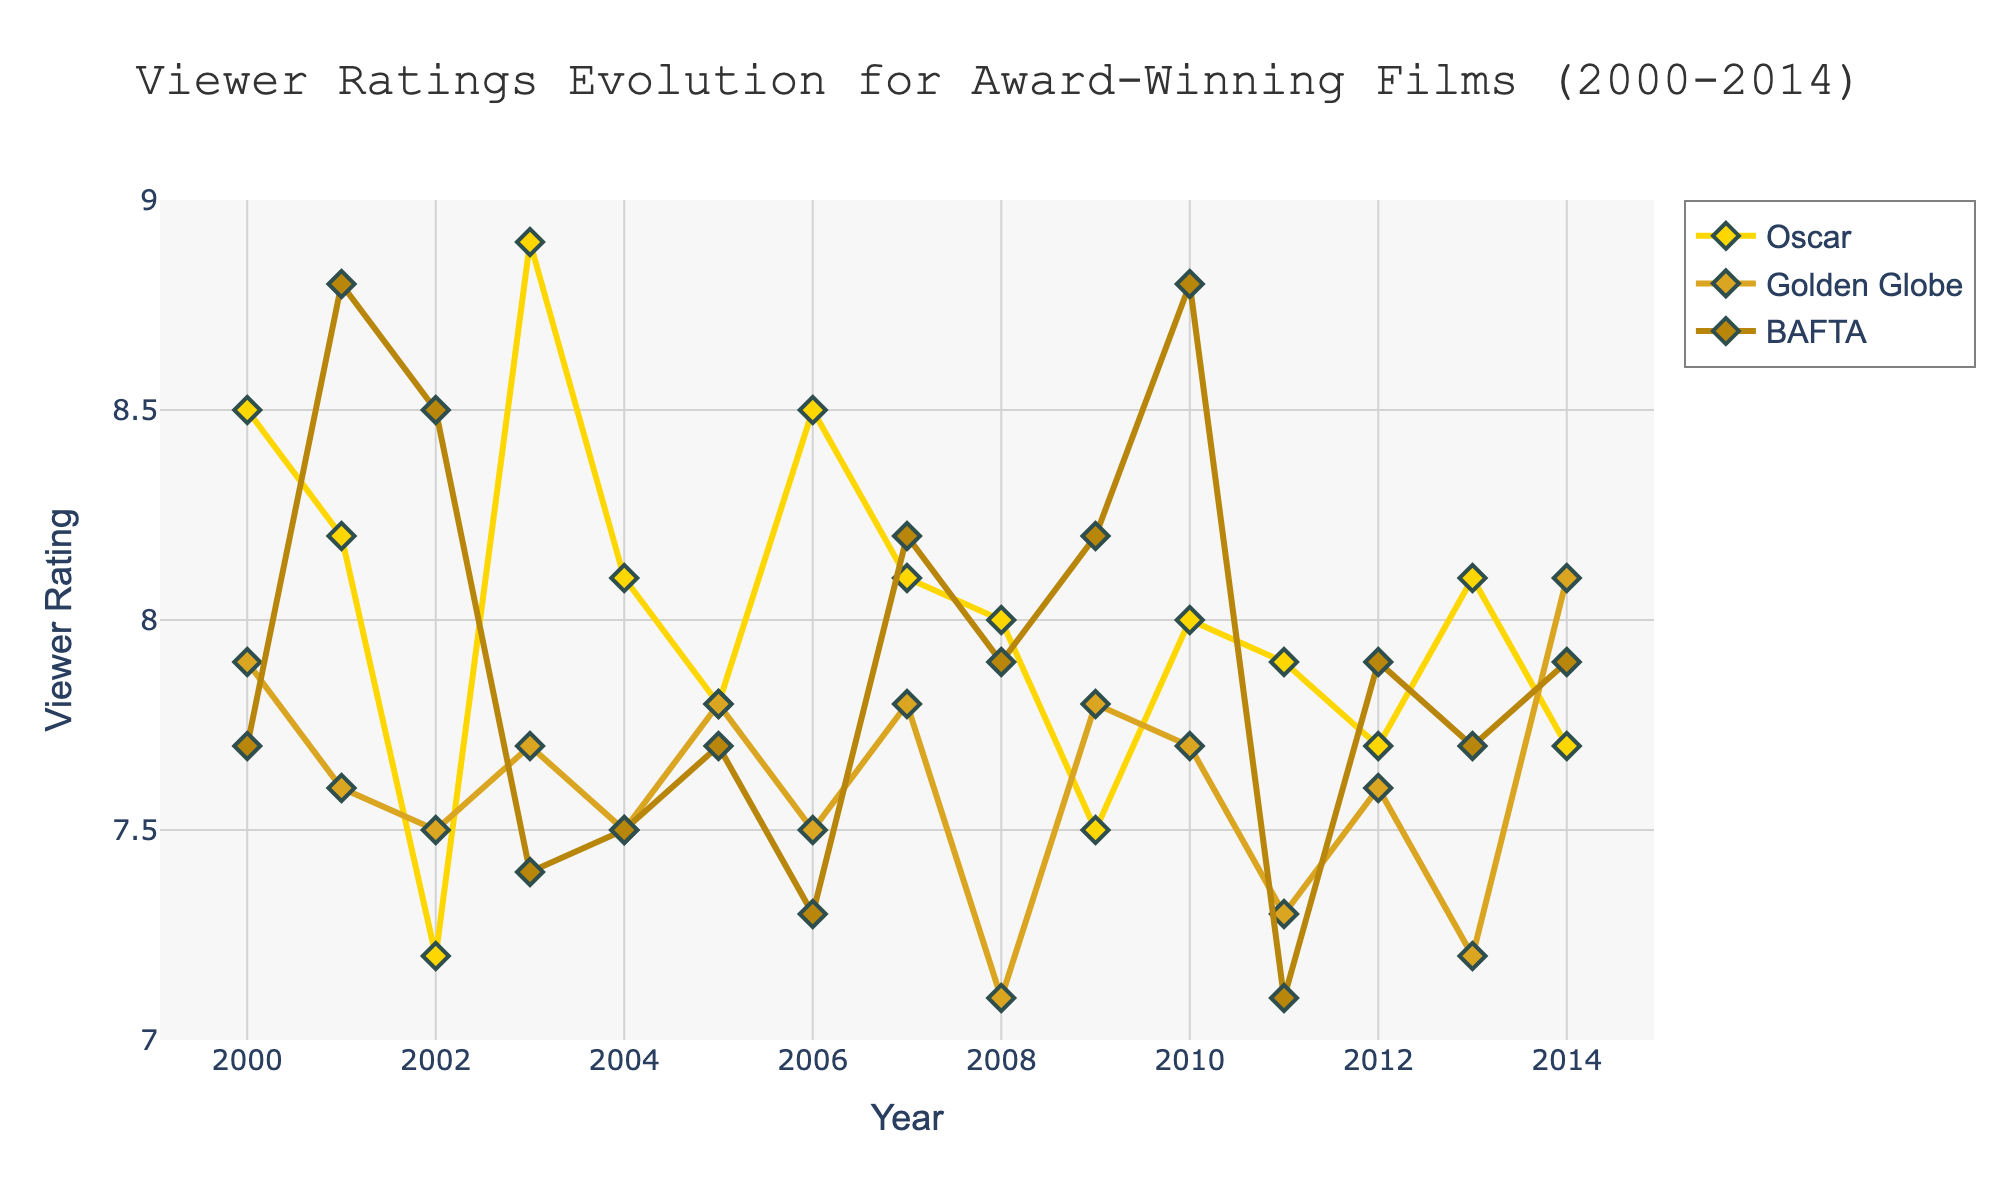What's the title of the figure? The title is usually placed at the top center of the figure. From this figure, the title directly indicates the content.
Answer: Viewer Ratings Evolution for Award-Winning Films (2000-2014) What is the average viewer rating of Oscar-winning films from 2000 to 2014? To find the average, sum up the viewer ratings of all Oscar-winning films and then divide by the number of those films. (8.5+8.2+7.2+8.9+8.1+7.8+8.5+8.1+8.0+7.5+8.0+7.9+7.7+8.1+7.7)/15 = 120.6/15 = 8.04
Answer: 8.04 What's the viewer rating trend for BAFTA-winning films from 2000 to 2014? Observe the general trend by looking at the ratings' increase or decrease over time for BAFTA-winning films. The ratings fluctuate, but there's no strong increasing or decreasing trend.
Answer: Fluctuating with no strong trend Which award type has the highest viewer rating in 2010? Compare the viewer ratings for all award types in the year 2010. Oscar: 8.0, Golden Globe: 7.7, BAFTA: 8.8. The BAFTA-winning film 'Inception' has the highest viewer rating.
Answer: BAFTA In 2003, which award-winning film had the highest viewer rating? Look at the viewer ratings for all the award-winning films in 2003. Oscar: 8.9, Golden Globe: 7.7, BAFTA: 7.4. The Oscar-winning film 'The Lord of the Rings: The Return of the King' has the highest viewer rating.
Answer: The Lord of the Rings: The Return of the King Compare the average viewer ratings of films that won BAFTA and Golden Globe awards from 2000 to 2014. Which one is higher? Calculate each average separately. BAFTA: (7.7+8.8+8.5+7.4+7.5+7.7+8.2+7.9+8.2+8.8+7.1+7.9+7.7+7.9) / 15 = 122.4 / 15 = 8.16. Golden Globe: (7.9+7.6+7.5+7.7+7.5+7.8+8.1+7.1+7.8+7.7+7.3+7.6+7.2+8.1) / 15 = 115.7 / 15 = 7.71. BAFTA's average is higher.
Answer: BAFTA Which film had the lowest viewer rating among the Oscar winners? Look at the viewer ratings for all Oscar-winning films and identify the lowest value. The film 'Chicago' in 2002 has the lowest viewer rating of 7.2.
Answer: Chicago (7.2) Did the viewer ratings of Golden Globe-winning films show improvement over time from 2000 to 2014? Observe the viewer ratings of Golden Globe-winning films over the years to see if there's a general upward trend. The ratings fluctuate without a clear upward or downward trend.
Answer: No clear trend 